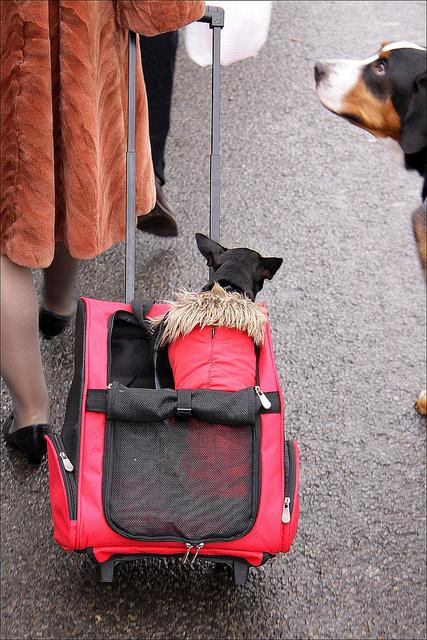What type of shoes does the woman have on? heels 